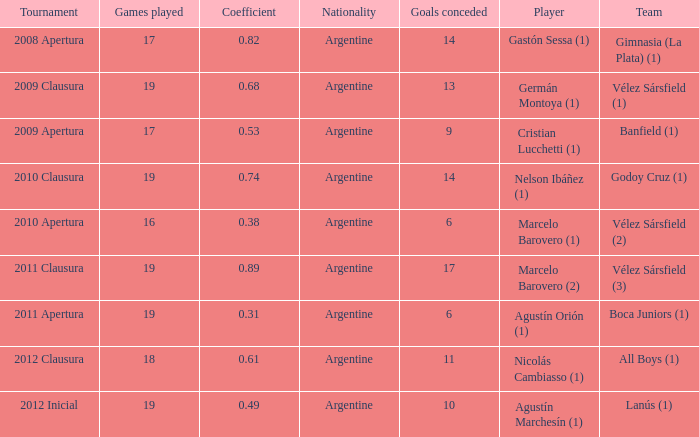How many nationalities are there for the 2011 apertura? 1.0. 